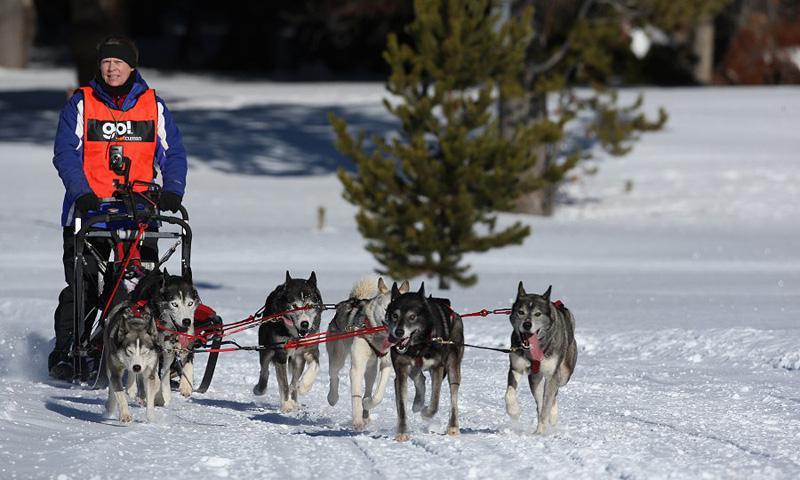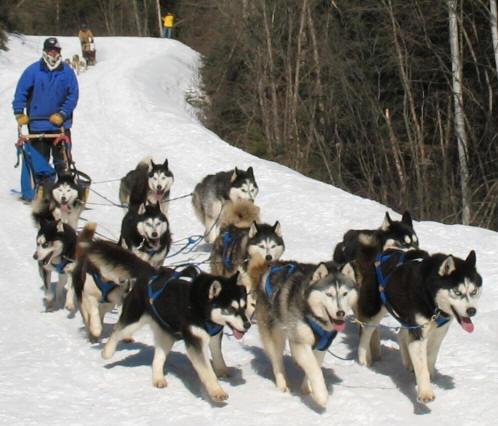The first image is the image on the left, the second image is the image on the right. Given the left and right images, does the statement "There are at least two sets of sled dogs pulling a bundled up human behind them." hold true? Answer yes or no. Yes. The first image is the image on the left, the second image is the image on the right. Considering the images on both sides, is "Left image shows a rider with an orange vest at the left of the picture." valid? Answer yes or no. Yes. The first image is the image on the left, the second image is the image on the right. Given the left and right images, does the statement "The dogs are to the right of the sled in both pictures." hold true? Answer yes or no. Yes. 